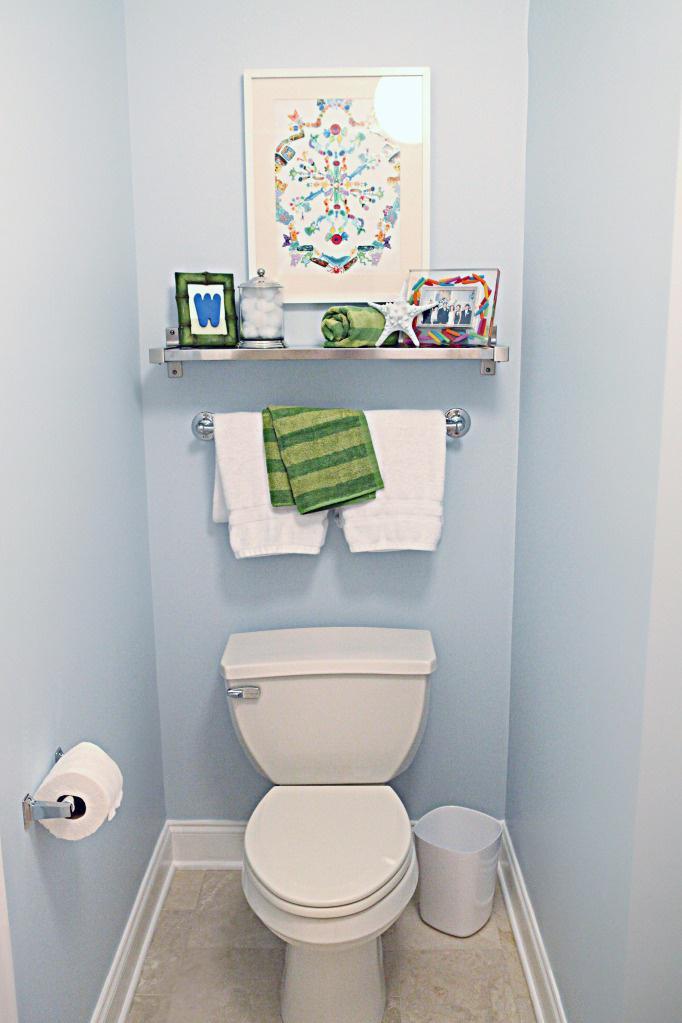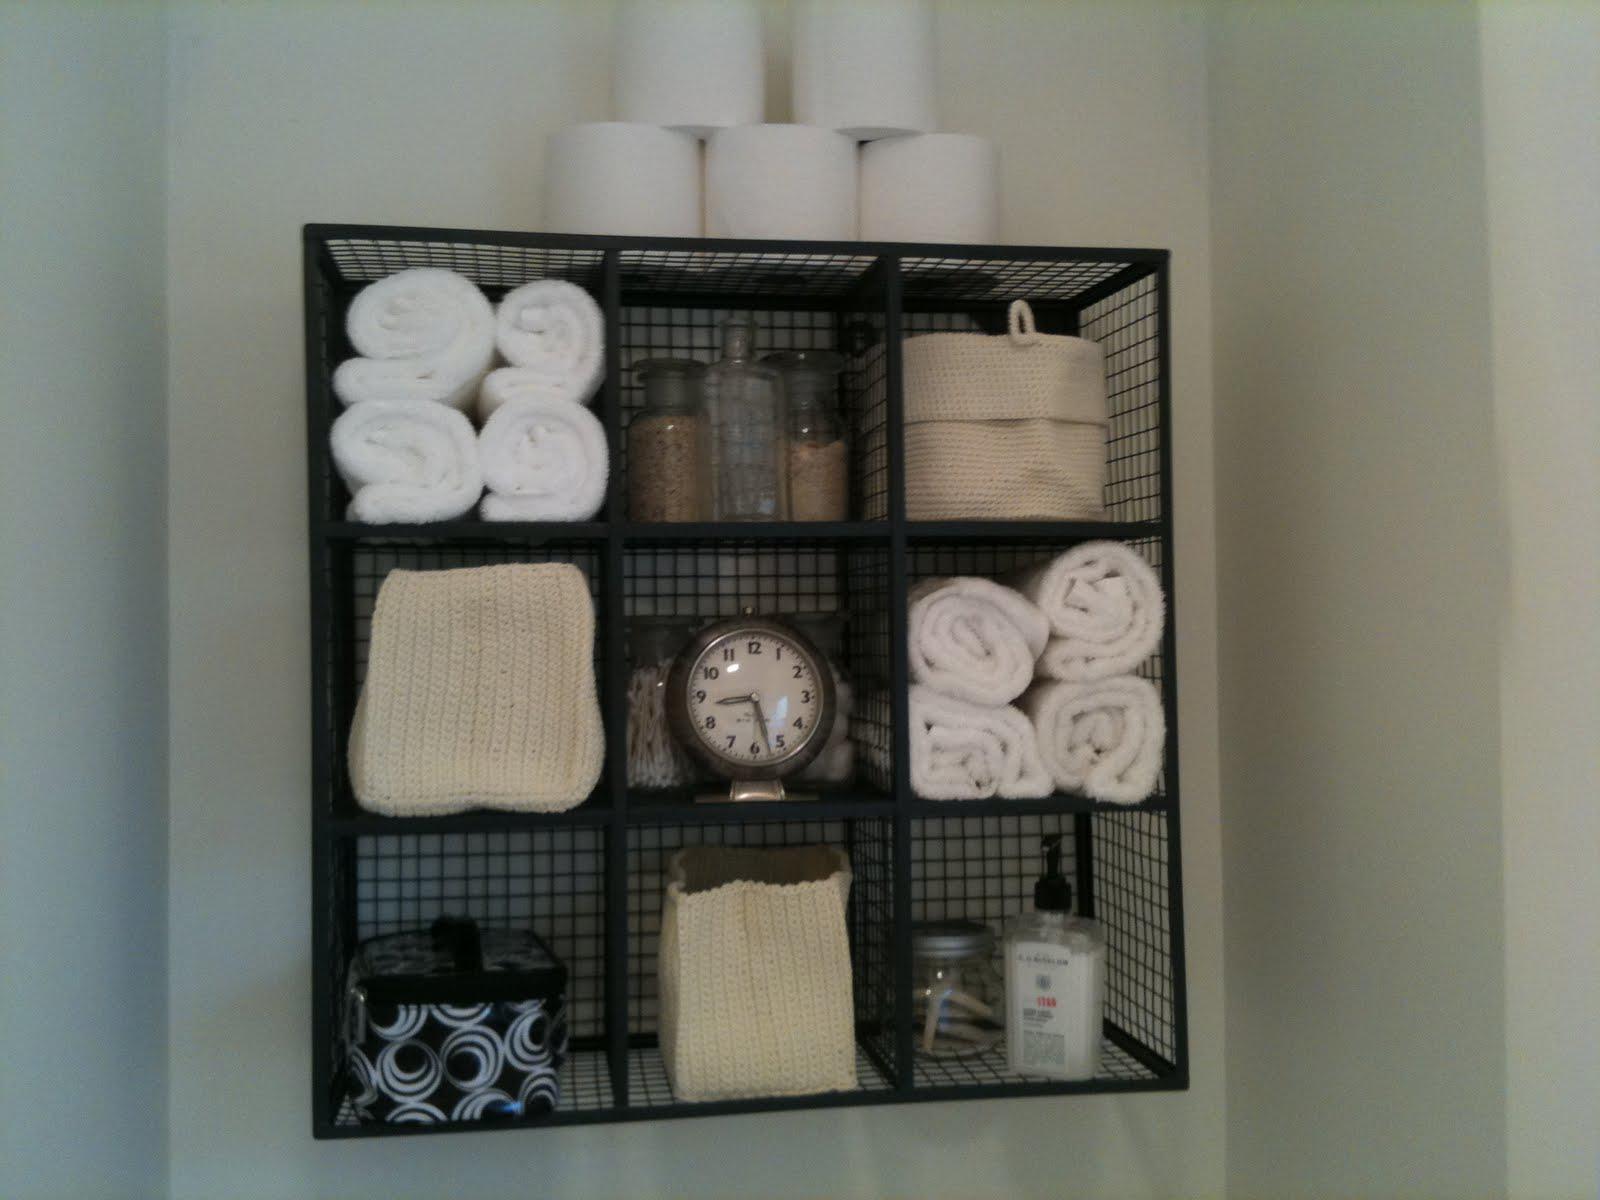The first image is the image on the left, the second image is the image on the right. Given the left and right images, does the statement "There is a toilet in the image on the left" hold true? Answer yes or no. Yes. 